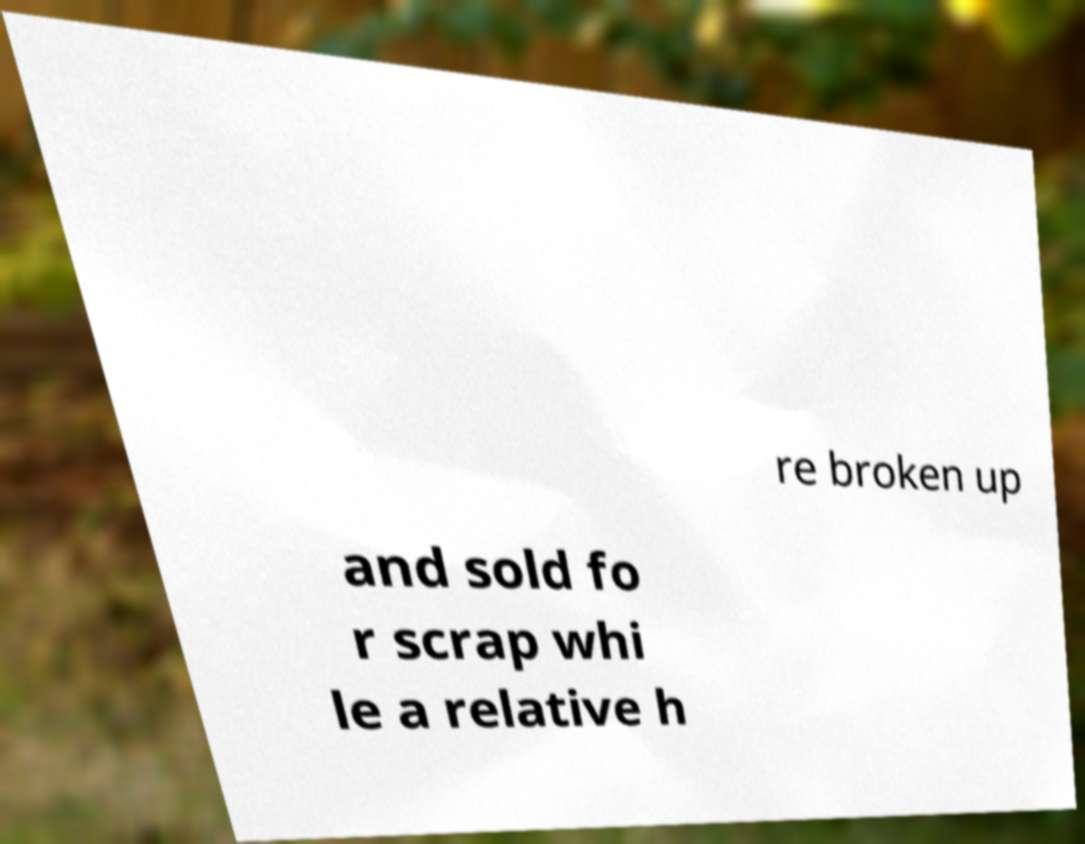I need the written content from this picture converted into text. Can you do that? re broken up and sold fo r scrap whi le a relative h 